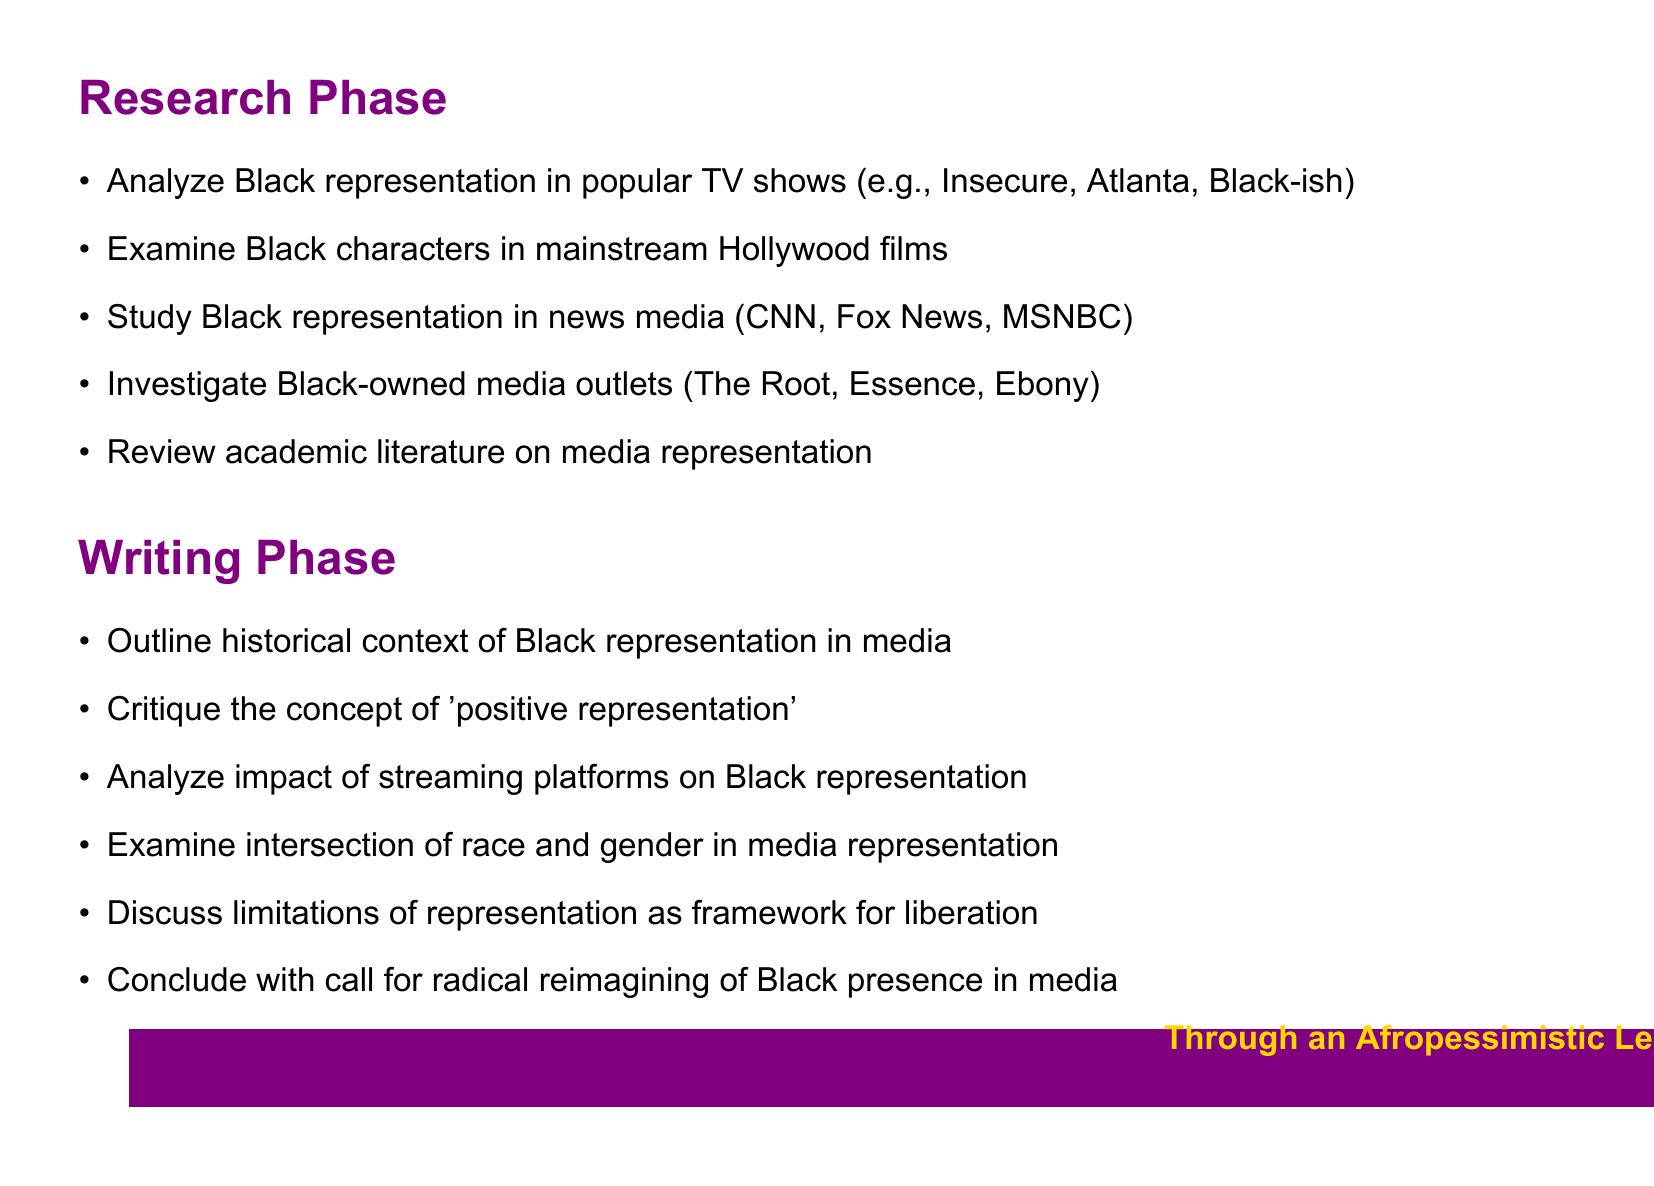What is one task in the research phase? The research phase includes various tasks related to analyzing and studying Black representation in media. An example is "Analyze Black representation in popular TV shows."
Answer: Analyze Black representation in popular TV shows Who are two key authors mentioned for reviewing academic literature? The document lists key authors related to media representation. Two examples are "Stuart Hall" and "bell hooks."
Answer: Stuart Hall, bell hooks Name one streaming platform analyzed in the writing phase. The writing phase includes analyzing the impact of streaming platforms on Black representation. One example given is "Netflix."
Answer: Netflix What concept is critiqued regarding representation? The writing phase discusses various points, such as critiquing the concept of "positive representation."
Answer: Positive representation How many tasks are listed in the writing phase? The writing phase includes multiple tasks related to analyzing and discussing media representation. There are six tasks listed.
Answer: Six 